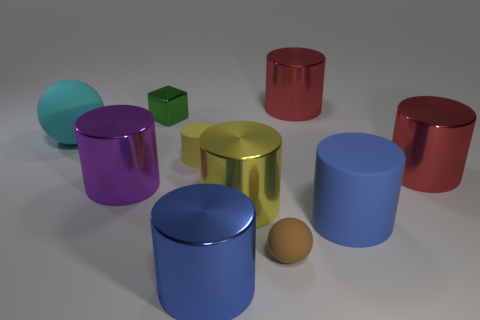There is a big cylinder to the left of the small yellow cylinder; is there a big yellow cylinder that is in front of it? Indeed, in the image, a large yellow cylinder is positioned in front of the smaller yellow cylinder, closer to the observer's perspective. 